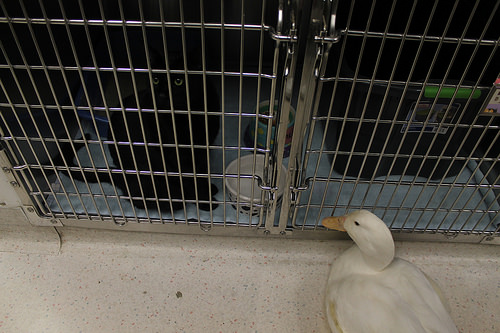<image>
Can you confirm if the bird is in front of the cat? Yes. The bird is positioned in front of the cat, appearing closer to the camera viewpoint. 